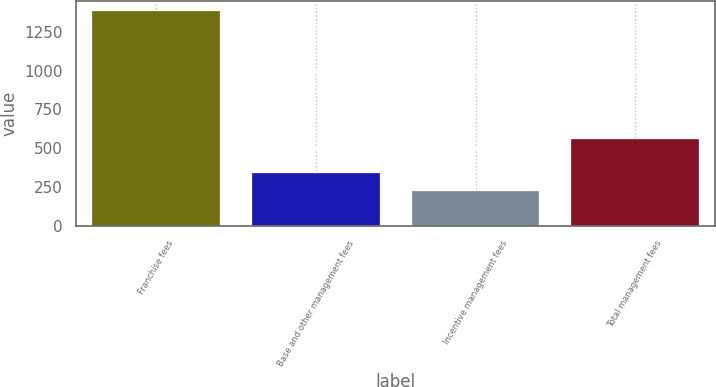Convert chart to OTSL. <chart><loc_0><loc_0><loc_500><loc_500><bar_chart><fcel>Franchise fees<fcel>Base and other management fees<fcel>Incentive management fees<fcel>Total management fees<nl><fcel>1382<fcel>338<fcel>222<fcel>558<nl></chart> 